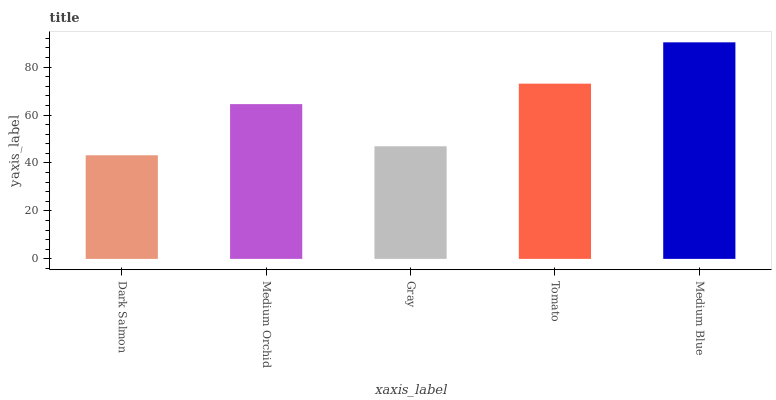Is Dark Salmon the minimum?
Answer yes or no. Yes. Is Medium Blue the maximum?
Answer yes or no. Yes. Is Medium Orchid the minimum?
Answer yes or no. No. Is Medium Orchid the maximum?
Answer yes or no. No. Is Medium Orchid greater than Dark Salmon?
Answer yes or no. Yes. Is Dark Salmon less than Medium Orchid?
Answer yes or no. Yes. Is Dark Salmon greater than Medium Orchid?
Answer yes or no. No. Is Medium Orchid less than Dark Salmon?
Answer yes or no. No. Is Medium Orchid the high median?
Answer yes or no. Yes. Is Medium Orchid the low median?
Answer yes or no. Yes. Is Tomato the high median?
Answer yes or no. No. Is Medium Blue the low median?
Answer yes or no. No. 